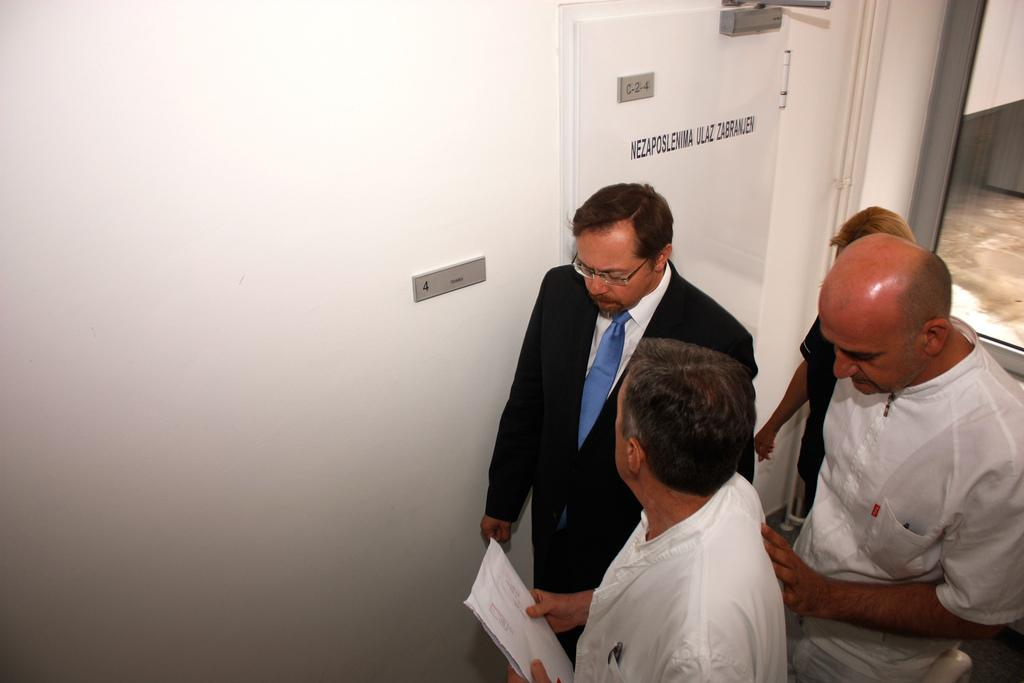Who or what is present in the image? There are people in the image. What can be seen in the background of the image? There is a wall in the background of the image. Can you describe any specific features of the wall? There is a door with text in the image. What type of architectural feature is visible on the right side of the image? There is a glass window on the right side of the image. What type of owl can be seen perched on the door in the image? There is no owl present in the image; the door has text on it. Can you describe the fire that is burning near the people in the image? There is no fire present in the image; the people are standing near a wall with a door and a glass window. 